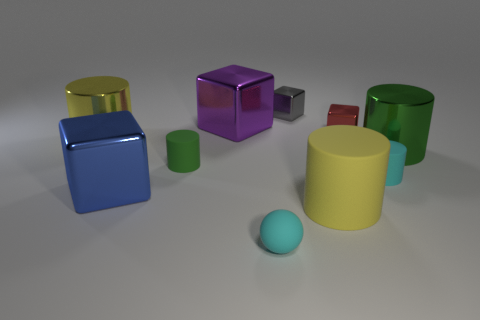What number of yellow metal things are the same size as the gray cube?
Offer a very short reply. 0. Are there any other matte objects that have the same color as the large rubber thing?
Keep it short and to the point. No. Is the tiny cyan cylinder made of the same material as the big green cylinder?
Make the answer very short. No. What number of large blue metallic objects are the same shape as the purple object?
Give a very brief answer. 1. What is the shape of the purple thing that is the same material as the blue thing?
Make the answer very short. Cube. What is the color of the big cube to the left of the small cylinder that is left of the cyan sphere?
Your answer should be compact. Blue. Do the matte sphere and the large rubber thing have the same color?
Provide a succinct answer. No. There is a green cylinder in front of the green cylinder that is right of the small gray shiny block; what is its material?
Offer a very short reply. Rubber. What material is the other yellow object that is the same shape as the large yellow metallic object?
Provide a succinct answer. Rubber. There is a big yellow cylinder in front of the thing that is to the left of the large blue object; is there a large rubber thing that is in front of it?
Your answer should be very brief. No. 